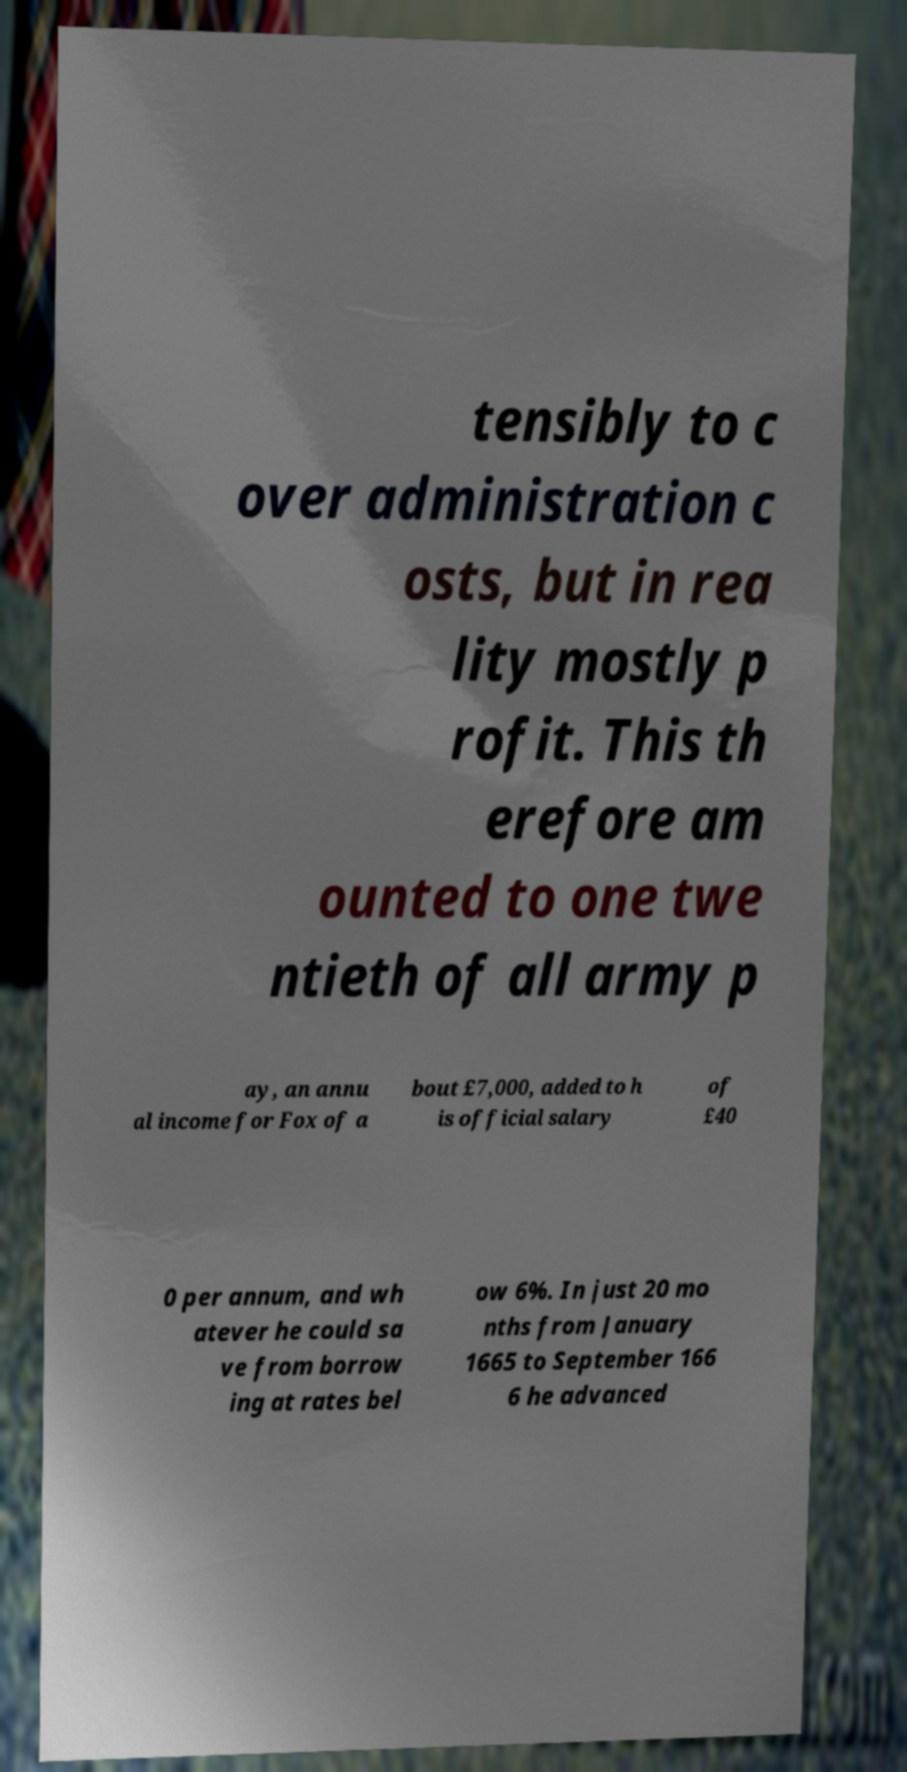There's text embedded in this image that I need extracted. Can you transcribe it verbatim? tensibly to c over administration c osts, but in rea lity mostly p rofit. This th erefore am ounted to one twe ntieth of all army p ay, an annu al income for Fox of a bout £7,000, added to h is official salary of £40 0 per annum, and wh atever he could sa ve from borrow ing at rates bel ow 6%. In just 20 mo nths from January 1665 to September 166 6 he advanced 